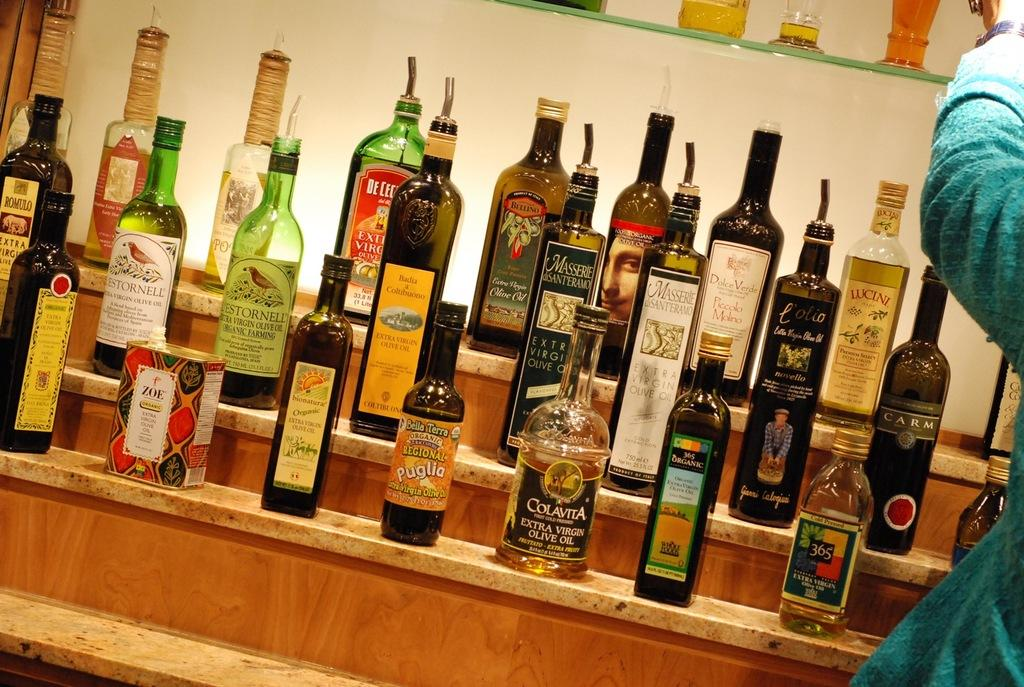What objects are placed on racks in the image? There are bottles placed on racks in the image. What can be seen in the background of the image? There is a wall in the background of the image. Is there anyone present in the image? Yes, there is a person standing in the image. What type of plastic is being used to create bubbles in the image? There is no plastic or bubbles present in the image. What kind of quilt is being used to cover the bottles in the image? There is no quilt present in the image; the bottles are placed on racks. 